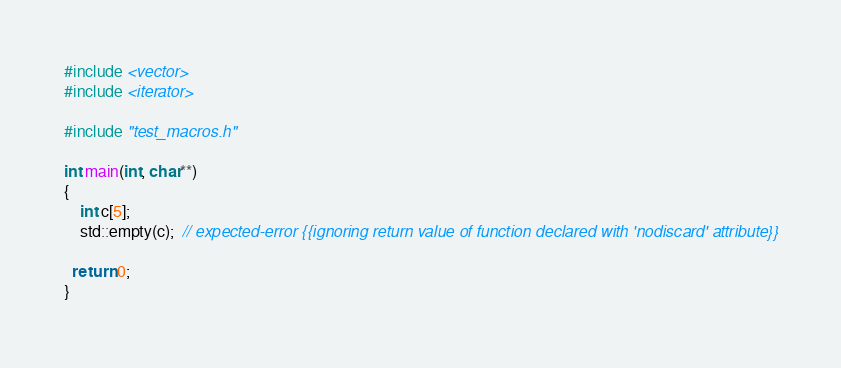Convert code to text. <code><loc_0><loc_0><loc_500><loc_500><_C++_>
#include <vector>
#include <iterator>

#include "test_macros.h"

int main(int, char**)
{
    int c[5];
    std::empty(c);  // expected-error {{ignoring return value of function declared with 'nodiscard' attribute}}

  return 0;
}
</code> 